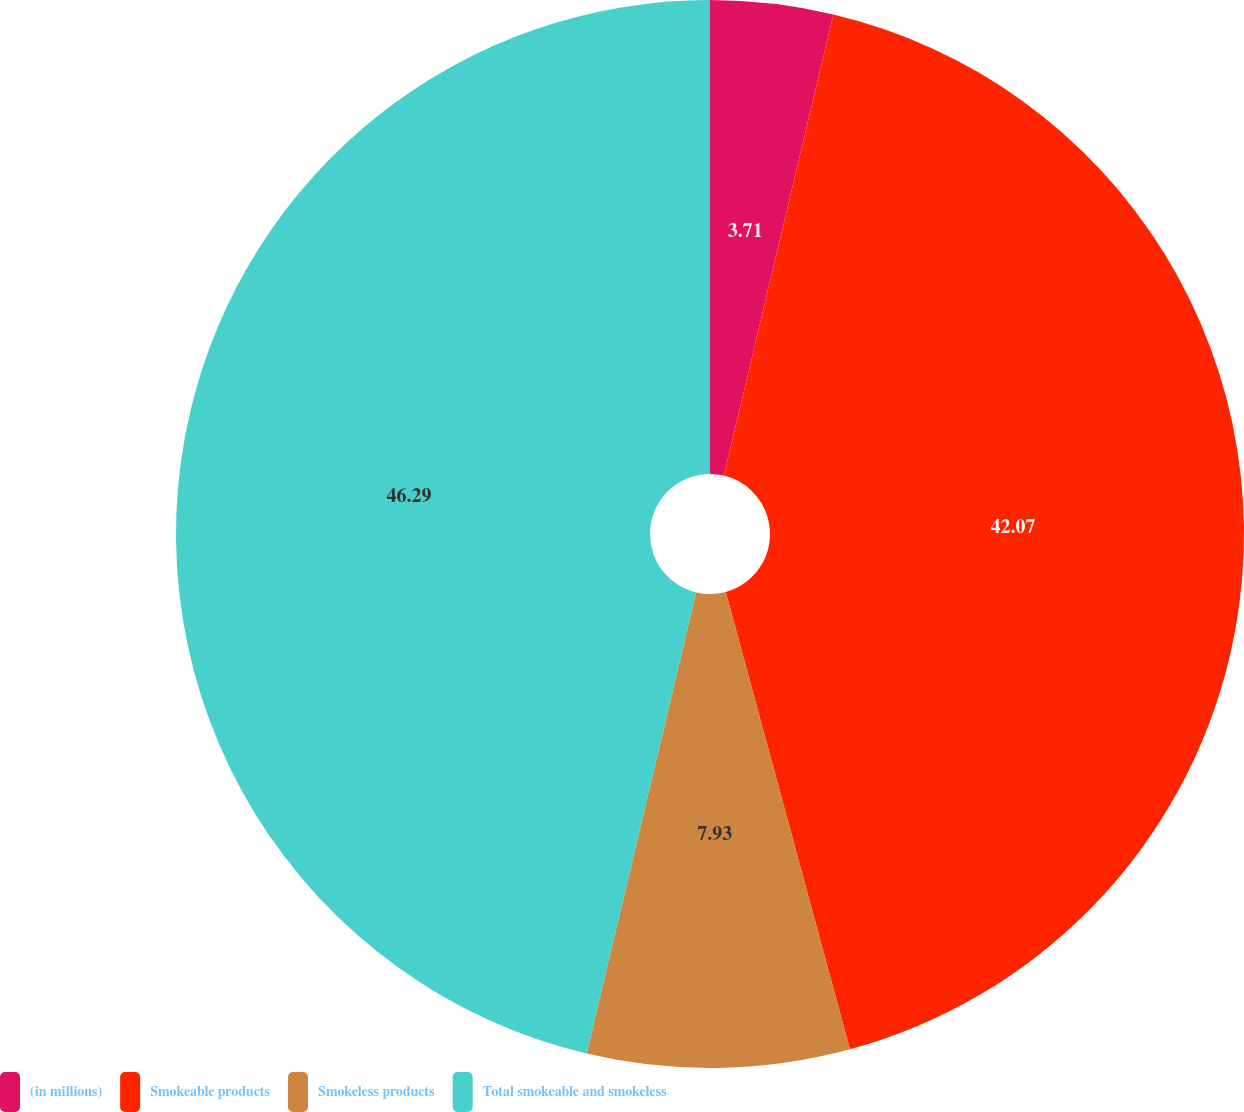<chart> <loc_0><loc_0><loc_500><loc_500><pie_chart><fcel>(in millions)<fcel>Smokeable products<fcel>Smokeless products<fcel>Total smokeable and smokeless<nl><fcel>3.71%<fcel>42.07%<fcel>7.93%<fcel>46.29%<nl></chart> 